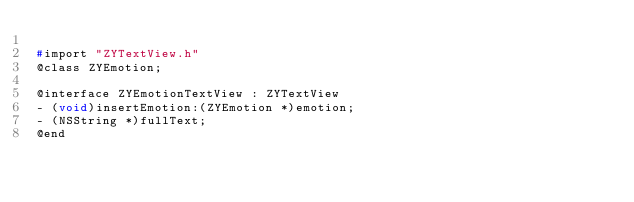Convert code to text. <code><loc_0><loc_0><loc_500><loc_500><_C_>
#import "ZYTextView.h"
@class ZYEmotion;

@interface ZYEmotionTextView : ZYTextView
- (void)insertEmotion:(ZYEmotion *)emotion;
- (NSString *)fullText;
@end
</code> 